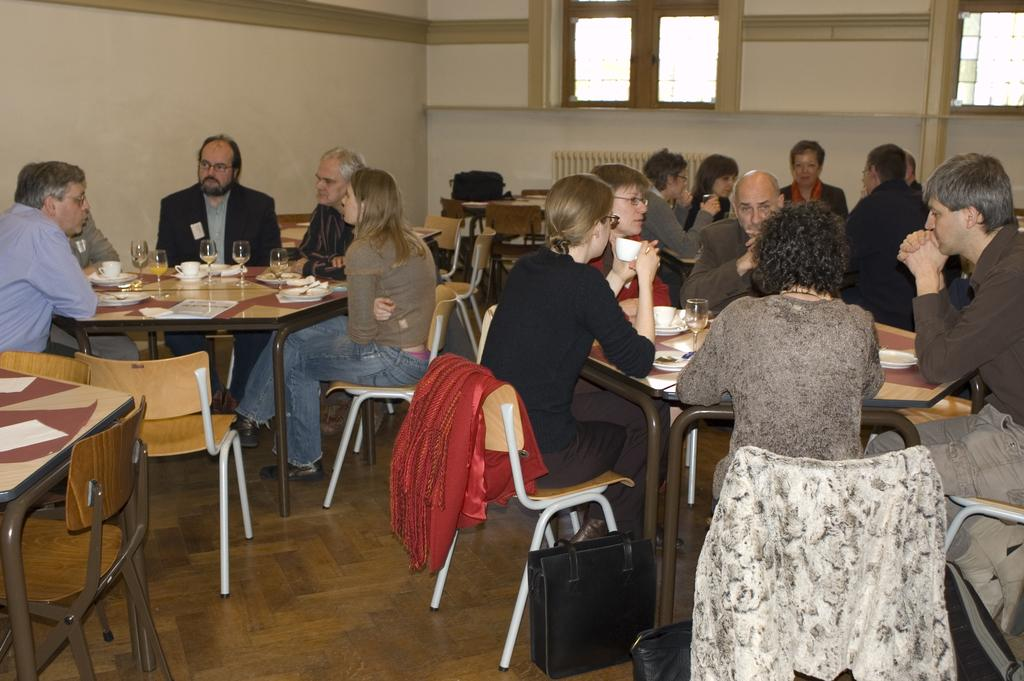How many individuals are present in the image? There are many people in the image. What are the people doing in the image? The people are sitting in chairs. What is located in front of the chairs? There is a table in front of the chairs. Where does the scene take place? The scene takes place in a room. What month is depicted in the image? There is no specific month depicted in the image; it is a general scene of people sitting in chairs in a room. 